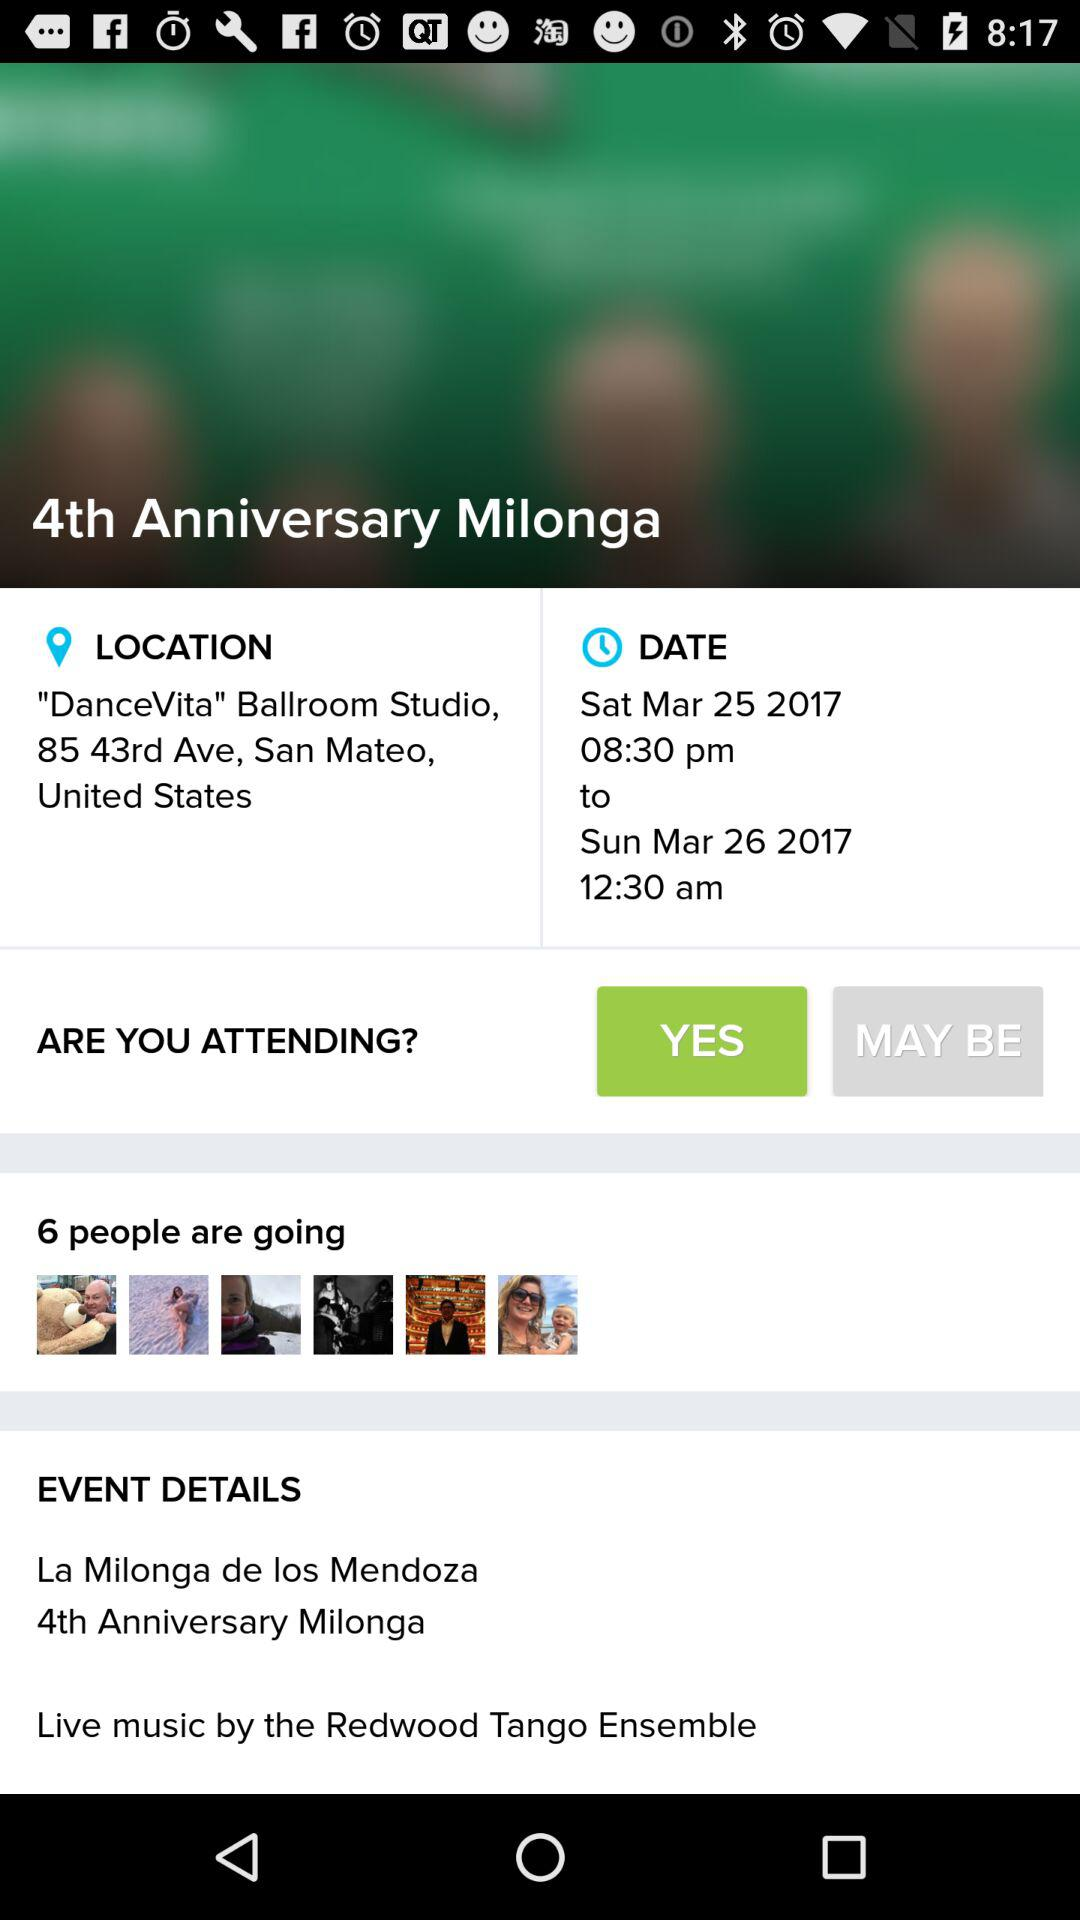Can we bring buddies?
When the provided information is insufficient, respond with <no answer>. <no answer> 